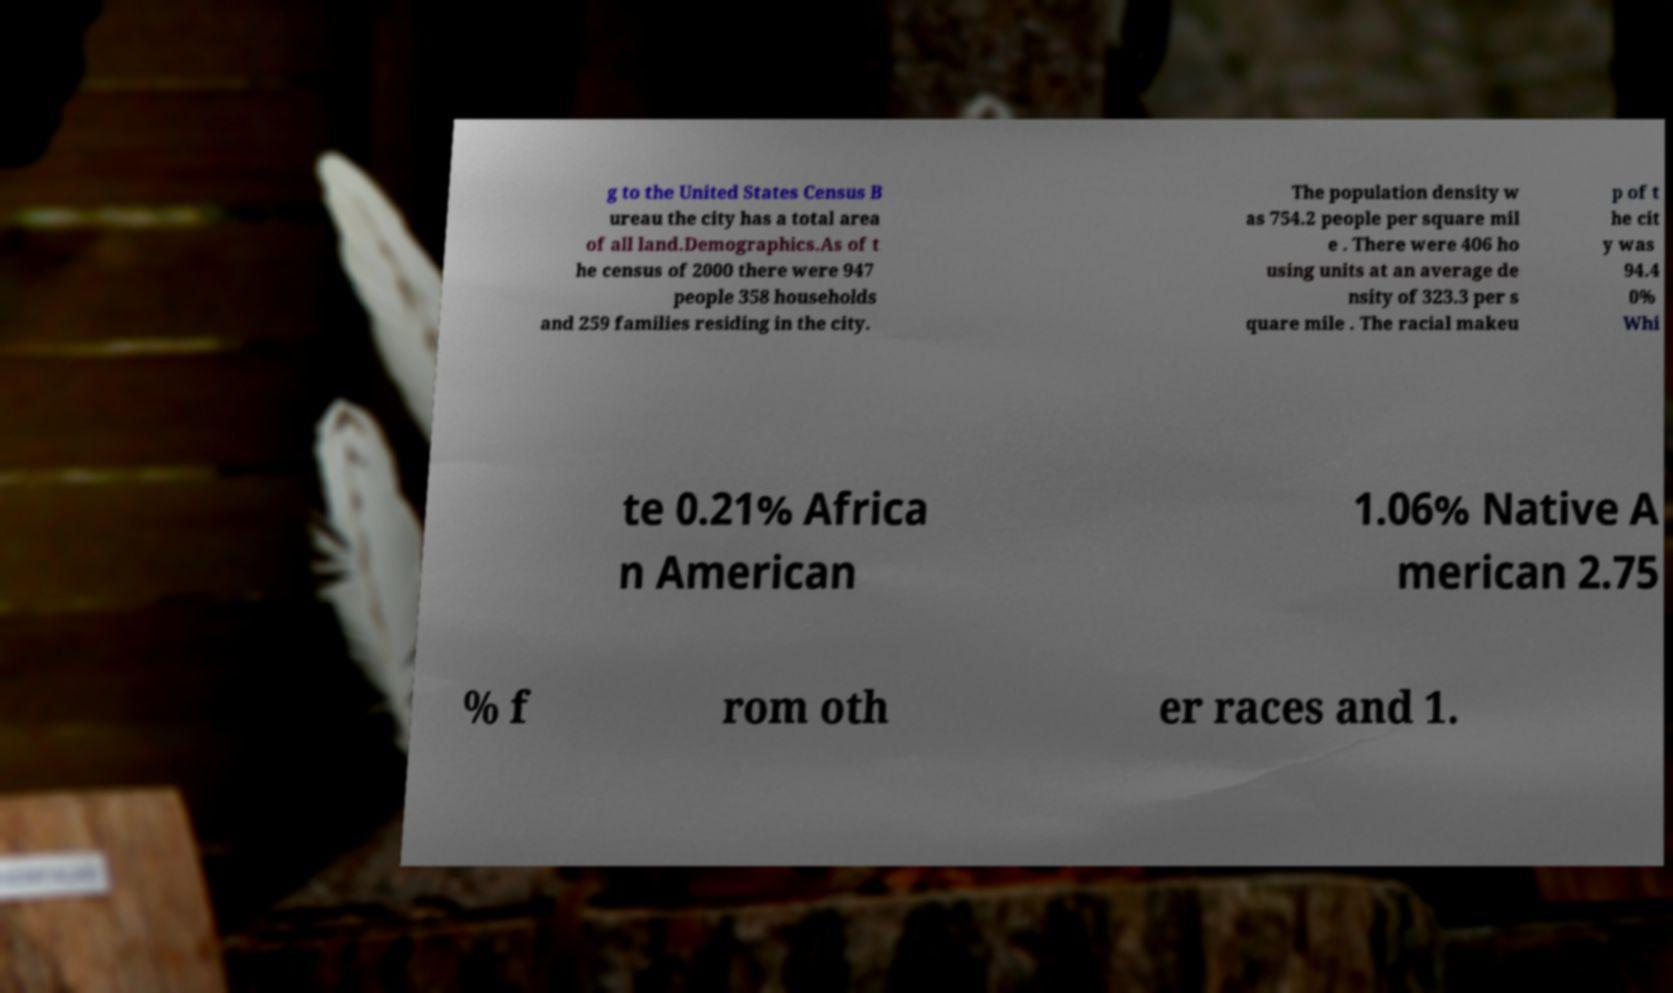For documentation purposes, I need the text within this image transcribed. Could you provide that? g to the United States Census B ureau the city has a total area of all land.Demographics.As of t he census of 2000 there were 947 people 358 households and 259 families residing in the city. The population density w as 754.2 people per square mil e . There were 406 ho using units at an average de nsity of 323.3 per s quare mile . The racial makeu p of t he cit y was 94.4 0% Whi te 0.21% Africa n American 1.06% Native A merican 2.75 % f rom oth er races and 1. 